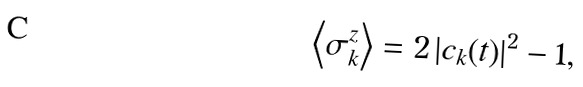Convert formula to latex. <formula><loc_0><loc_0><loc_500><loc_500>\left \langle \sigma _ { k } ^ { z } \right \rangle = 2 \left | c _ { k } ( t ) \right | ^ { 2 } - 1 ,</formula> 